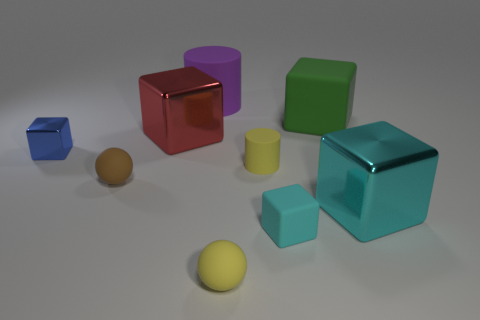Subtract all yellow cylinders. Subtract all brown cubes. How many cylinders are left? 1 Add 1 large purple cylinders. How many objects exist? 10 Subtract all cylinders. How many objects are left? 7 Add 2 tiny rubber objects. How many tiny rubber objects exist? 6 Subtract 1 blue blocks. How many objects are left? 8 Subtract all cyan rubber things. Subtract all small purple matte cubes. How many objects are left? 8 Add 6 cyan metallic cubes. How many cyan metallic cubes are left? 7 